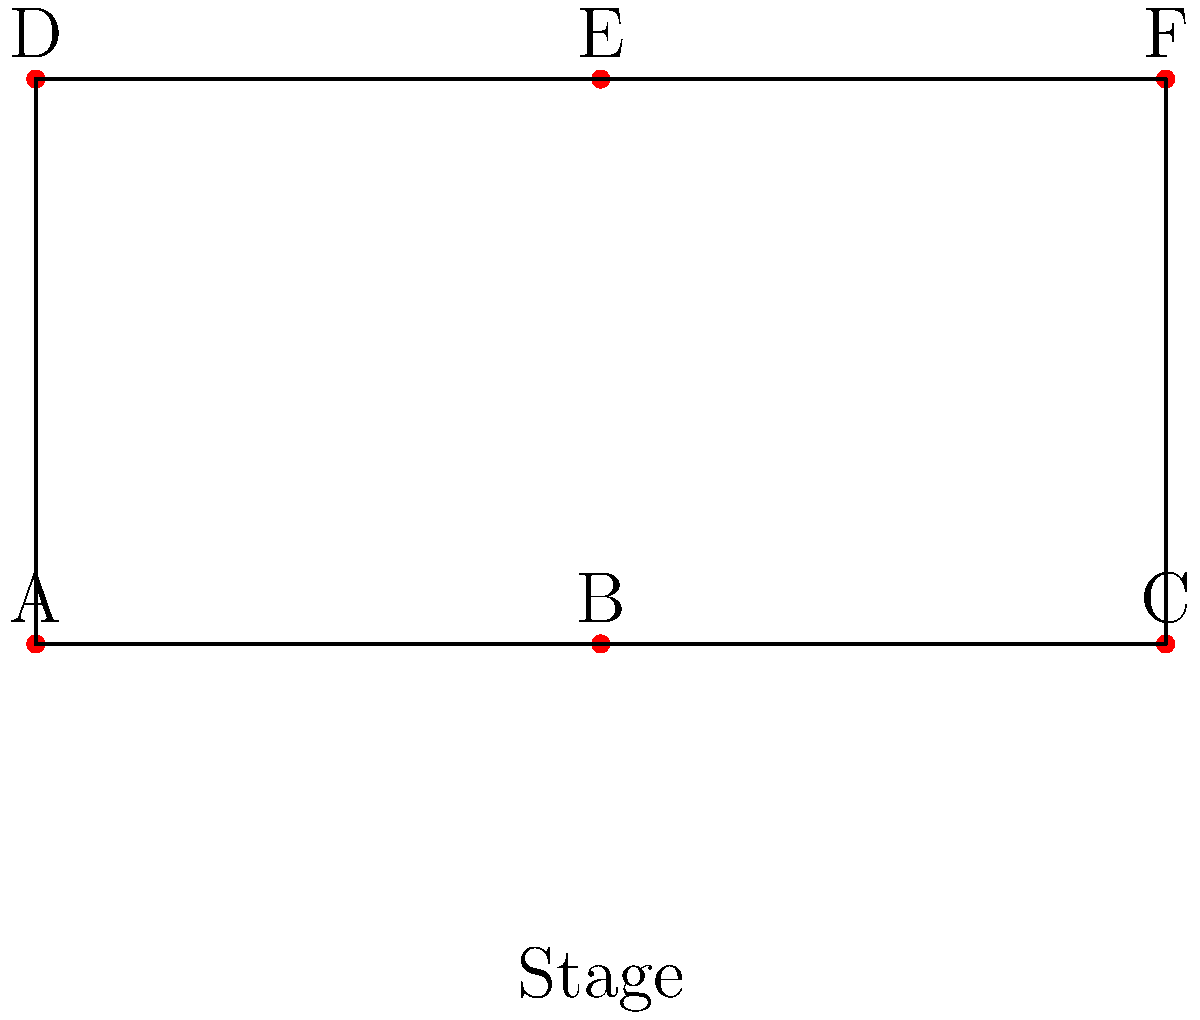In a scene from your favorite romance novel, six characters need to be arranged on a theater stage. The protagonist couple should be in the center, with their best friends on either side, and the antagonists at the corners. How should the characters be positioned if:

A: Female protagonist
B: Male protagonist
C: Female antagonist
D: Male antagonist
E: Female best friend
F: Male best friend

Provide the correct arrangement using the letters A-F, starting from the top-left corner and moving clockwise. To arrange the characters according to the given criteria, let's follow these steps:

1. Identify the protagonist couple: A (Female protagonist) and B (Male protagonist)
2. Identify their best friends: E (Female best friend) and F (Male best friend)
3. Identify the antagonists: C (Female antagonist) and D (Male antagonist)

Now, let's position them on the stage:

1. The protagonist couple (A and B) should be in the center, which corresponds to positions E and B on the diagram.
2. The best friends (E and F) should be on either side of the couple, which corresponds to positions F and C on the diagram.
3. The antagonists (C and D) should be at the corners, which corresponds to positions A and D on the diagram.

Starting from the top-left corner and moving clockwise, the correct arrangement is:

D (top-left) -> F (top-center) -> C (top-right) -> B (bottom-right) -> E (bottom-center) -> A (bottom-left)
Answer: DFCBEA 